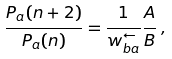<formula> <loc_0><loc_0><loc_500><loc_500>\frac { P _ { a } ( n + 2 ) } { P _ { a } ( n ) } = \frac { 1 } { w _ { b a } ^ { \leftarrow } } \frac { A } { B } \, ,</formula> 